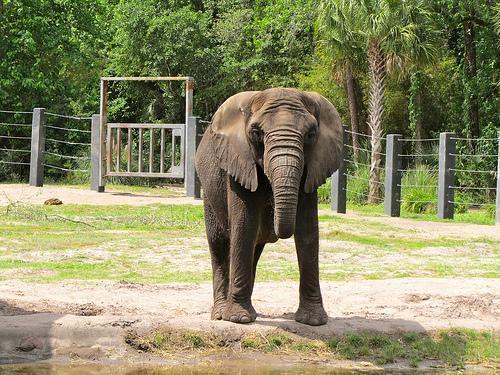How many elephants in the fence?
Give a very brief answer. 1. 